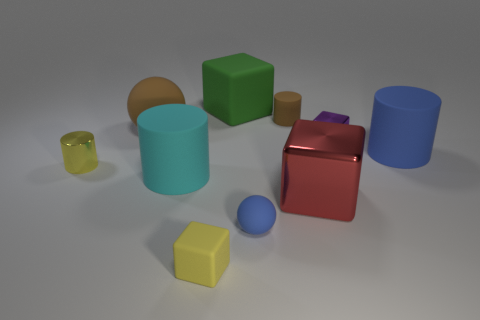There is a yellow cylinder that is the same size as the brown cylinder; what is it made of?
Provide a succinct answer. Metal. There is a cube that is in front of the small purple metal cube and to the right of the brown matte cylinder; what is its material?
Your response must be concise. Metal. Are any green rubber blocks visible?
Offer a very short reply. Yes. Do the small matte ball and the matte sphere that is behind the small blue matte thing have the same color?
Keep it short and to the point. No. There is a big object that is the same color as the small ball; what is its material?
Make the answer very short. Rubber. Are there any other things that are the same shape as the small yellow metal thing?
Provide a short and direct response. Yes. What is the shape of the blue rubber thing that is behind the small yellow thing that is on the left side of the big object on the left side of the cyan rubber cylinder?
Offer a very short reply. Cylinder. The tiny purple thing is what shape?
Your answer should be compact. Cube. There is a sphere in front of the large brown matte ball; what is its color?
Give a very brief answer. Blue. Do the yellow object that is in front of the cyan rubber cylinder and the large ball have the same size?
Offer a terse response. No. 